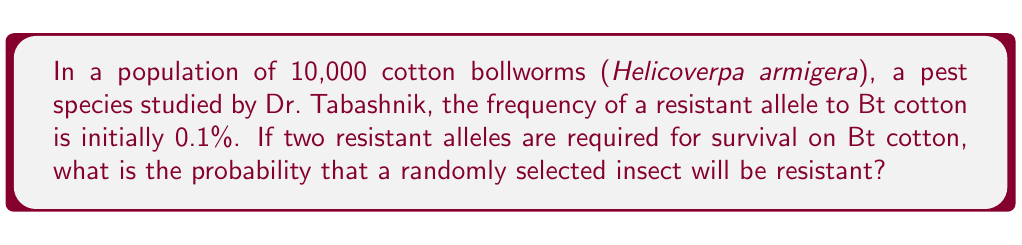Give your solution to this math problem. Let's approach this step-by-step:

1) First, we need to identify the genetic model. This is a case of recessive resistance, where two copies of the resistant allele are needed for the insect to be resistant.

2) Let's define our variables:
   $p$ = frequency of the resistant allele = 0.001 (0.1%)
   $q$ = frequency of the susceptible allele = 1 - $p$ = 0.999

3) In a diploid organism, the probability of being homozygous for the resistant allele (RR) is given by the square of the allele frequency:

   $$P(RR) = p^2$$

4) Substituting our value:

   $$P(RR) = (0.001)^2 = 0.000001$$

5) This means that the probability of a randomly selected insect being resistant is 0.000001, or 1 in 1,000,000.

6) We can verify this by calculating the expected number of resistant insects in the population:

   $$10,000 \times 0.000001 = 0.01$$

   This indicates that we would expect about 1 resistant insect in every 100,000 insects.
Answer: 0.000001 